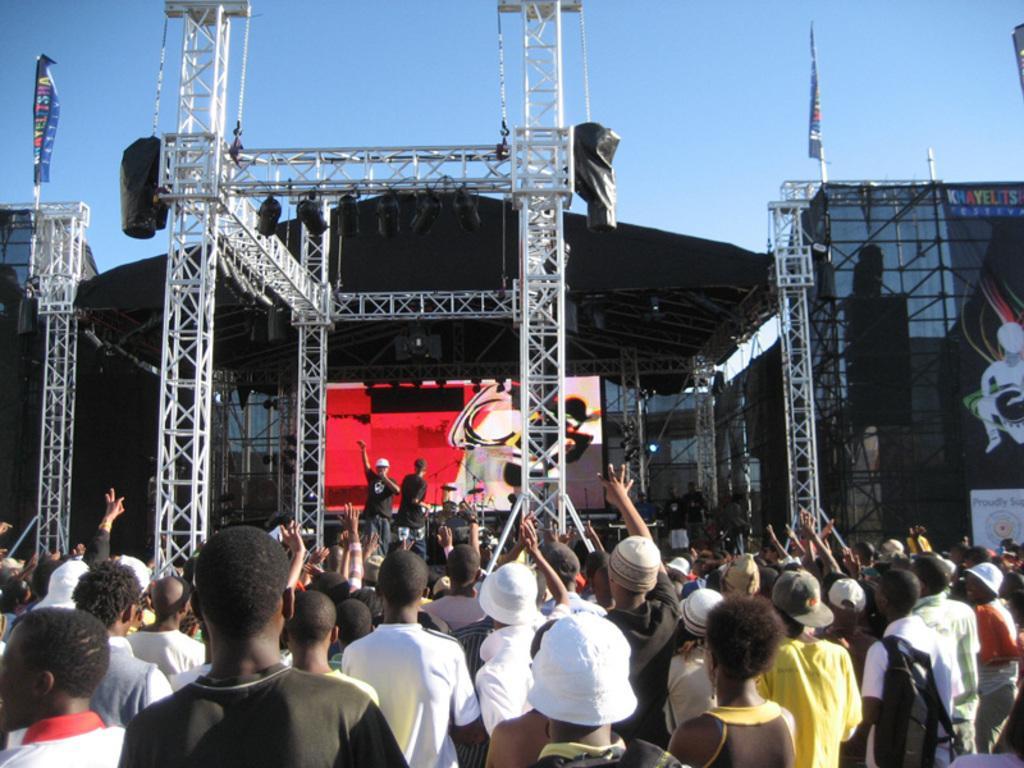In one or two sentences, can you explain what this image depicts? In the center of the image, we can see a stage and there are lights, we can see people standing on the stage and there is a crowd. At the top, there is a sky. 